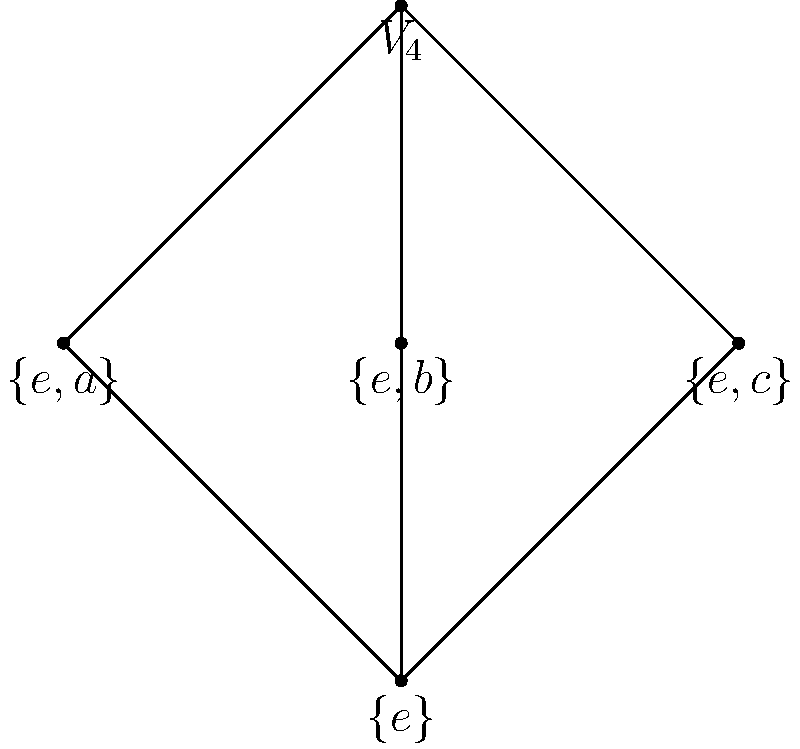In the subgroup lattice of the Klein four-group $V_4$ shown above, how many maximal subgroups are there? Provide a brief justification for your answer, referencing the classical group theory principles involved. To determine the number of maximal subgroups in the Klein four-group $V_4$, we need to understand the concept of maximal subgroups and analyze the given lattice diagram. Let's proceed step-by-step:

1. Definition: A maximal subgroup is a proper subgroup that is not contained in any other proper subgroup of the group.

2. Analysis of the lattice:
   - The lattice shows the subgroup structure of $V_4$.
   - At the bottom, we have the trivial subgroup $\{e\}$.
   - At the top, we have the full group $V_4$.
   - In between, we see three subgroups: $\{e,a\}$, $\{e,b\}$, and $\{e,c\}$.

3. Identifying maximal subgroups:
   - The subgroups $\{e,a\}$, $\{e,b\}$, and $\{e,c\}$ are directly connected to $V_4$.
   - These subgroups are not contained in any other proper subgroup of $V_4$.
   - Therefore, they are the maximal subgroups of $V_4$.

4. Classical group theory principles:
   - The Klein four-group $V_4$ is isomorphic to $C_2 \times C_2$ (the direct product of two cyclic groups of order 2).
   - In general, for elementary abelian $p$-groups (direct products of cyclic groups of prime order), the maximal subgroups are precisely those of index $p$.
   - Here, each maximal subgroup has index 2 in $V_4$, consistent with this principle.

5. Counting the maximal subgroups:
   - We can clearly see three subgroups that satisfy the definition of maximal subgroups.

Thus, the Klein four-group $V_4$ has exactly 3 maximal subgroups.
Answer: 3 maximal subgroups 